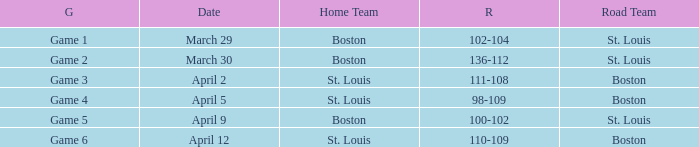What is the Game number on April 12 with St. Louis Home Team? Game 6. 